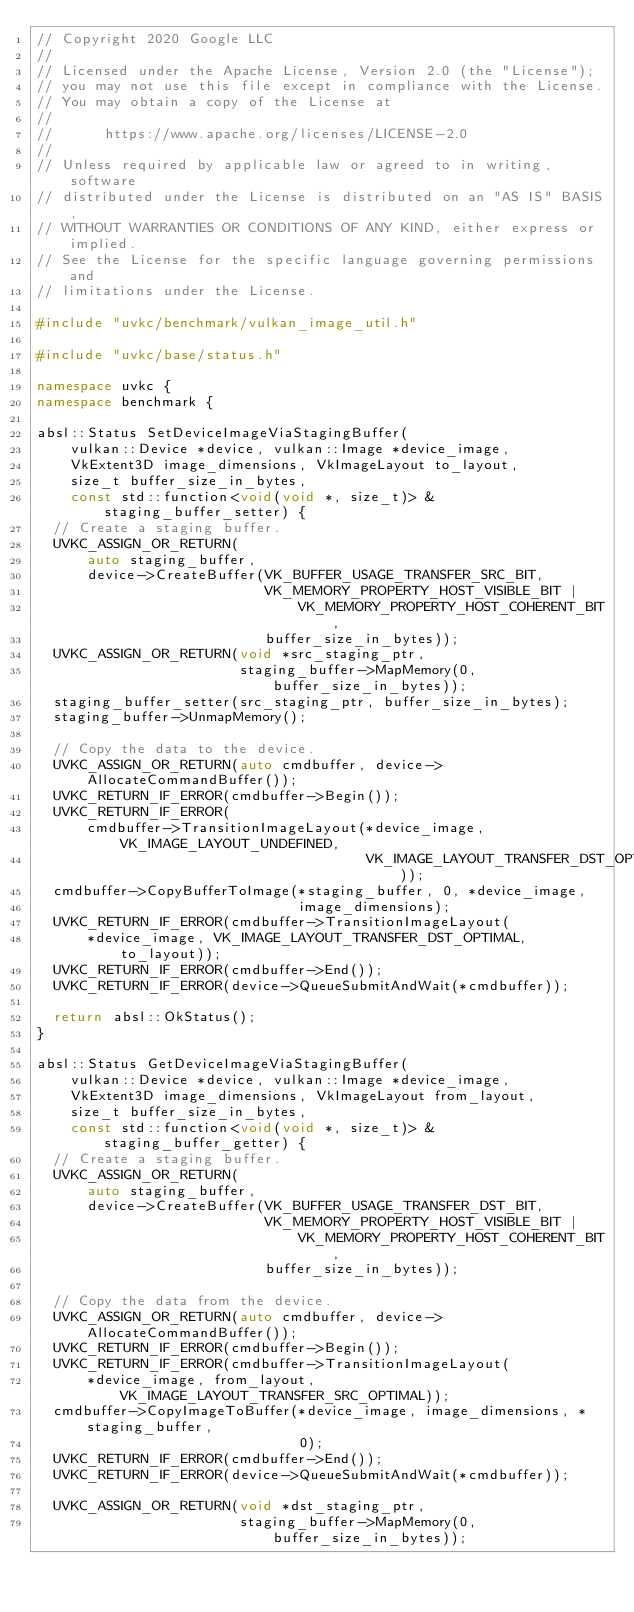<code> <loc_0><loc_0><loc_500><loc_500><_C++_>// Copyright 2020 Google LLC
//
// Licensed under the Apache License, Version 2.0 (the "License");
// you may not use this file except in compliance with the License.
// You may obtain a copy of the License at
//
//      https://www.apache.org/licenses/LICENSE-2.0
//
// Unless required by applicable law or agreed to in writing, software
// distributed under the License is distributed on an "AS IS" BASIS,
// WITHOUT WARRANTIES OR CONDITIONS OF ANY KIND, either express or implied.
// See the License for the specific language governing permissions and
// limitations under the License.

#include "uvkc/benchmark/vulkan_image_util.h"

#include "uvkc/base/status.h"

namespace uvkc {
namespace benchmark {

absl::Status SetDeviceImageViaStagingBuffer(
    vulkan::Device *device, vulkan::Image *device_image,
    VkExtent3D image_dimensions, VkImageLayout to_layout,
    size_t buffer_size_in_bytes,
    const std::function<void(void *, size_t)> &staging_buffer_setter) {
  // Create a staging buffer.
  UVKC_ASSIGN_OR_RETURN(
      auto staging_buffer,
      device->CreateBuffer(VK_BUFFER_USAGE_TRANSFER_SRC_BIT,
                           VK_MEMORY_PROPERTY_HOST_VISIBLE_BIT |
                               VK_MEMORY_PROPERTY_HOST_COHERENT_BIT,
                           buffer_size_in_bytes));
  UVKC_ASSIGN_OR_RETURN(void *src_staging_ptr,
                        staging_buffer->MapMemory(0, buffer_size_in_bytes));
  staging_buffer_setter(src_staging_ptr, buffer_size_in_bytes);
  staging_buffer->UnmapMemory();

  // Copy the data to the device.
  UVKC_ASSIGN_OR_RETURN(auto cmdbuffer, device->AllocateCommandBuffer());
  UVKC_RETURN_IF_ERROR(cmdbuffer->Begin());
  UVKC_RETURN_IF_ERROR(
      cmdbuffer->TransitionImageLayout(*device_image, VK_IMAGE_LAYOUT_UNDEFINED,
                                       VK_IMAGE_LAYOUT_TRANSFER_DST_OPTIMAL));
  cmdbuffer->CopyBufferToImage(*staging_buffer, 0, *device_image,
                               image_dimensions);
  UVKC_RETURN_IF_ERROR(cmdbuffer->TransitionImageLayout(
      *device_image, VK_IMAGE_LAYOUT_TRANSFER_DST_OPTIMAL, to_layout));
  UVKC_RETURN_IF_ERROR(cmdbuffer->End());
  UVKC_RETURN_IF_ERROR(device->QueueSubmitAndWait(*cmdbuffer));

  return absl::OkStatus();
}

absl::Status GetDeviceImageViaStagingBuffer(
    vulkan::Device *device, vulkan::Image *device_image,
    VkExtent3D image_dimensions, VkImageLayout from_layout,
    size_t buffer_size_in_bytes,
    const std::function<void(void *, size_t)> &staging_buffer_getter) {
  // Create a staging buffer.
  UVKC_ASSIGN_OR_RETURN(
      auto staging_buffer,
      device->CreateBuffer(VK_BUFFER_USAGE_TRANSFER_DST_BIT,
                           VK_MEMORY_PROPERTY_HOST_VISIBLE_BIT |
                               VK_MEMORY_PROPERTY_HOST_COHERENT_BIT,
                           buffer_size_in_bytes));

  // Copy the data from the device.
  UVKC_ASSIGN_OR_RETURN(auto cmdbuffer, device->AllocateCommandBuffer());
  UVKC_RETURN_IF_ERROR(cmdbuffer->Begin());
  UVKC_RETURN_IF_ERROR(cmdbuffer->TransitionImageLayout(
      *device_image, from_layout, VK_IMAGE_LAYOUT_TRANSFER_SRC_OPTIMAL));
  cmdbuffer->CopyImageToBuffer(*device_image, image_dimensions, *staging_buffer,
                               0);
  UVKC_RETURN_IF_ERROR(cmdbuffer->End());
  UVKC_RETURN_IF_ERROR(device->QueueSubmitAndWait(*cmdbuffer));

  UVKC_ASSIGN_OR_RETURN(void *dst_staging_ptr,
                        staging_buffer->MapMemory(0, buffer_size_in_bytes));</code> 